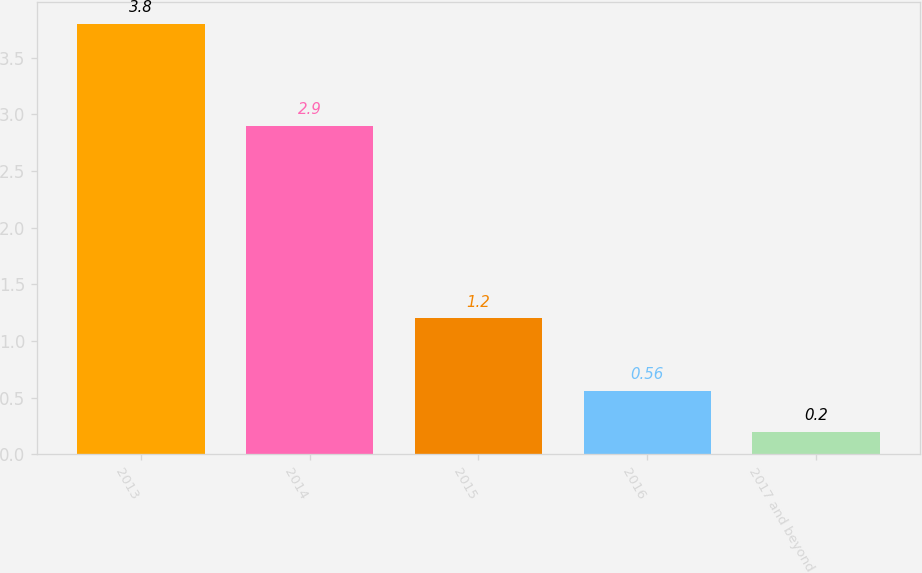<chart> <loc_0><loc_0><loc_500><loc_500><bar_chart><fcel>2013<fcel>2014<fcel>2015<fcel>2016<fcel>2017 and beyond<nl><fcel>3.8<fcel>2.9<fcel>1.2<fcel>0.56<fcel>0.2<nl></chart> 